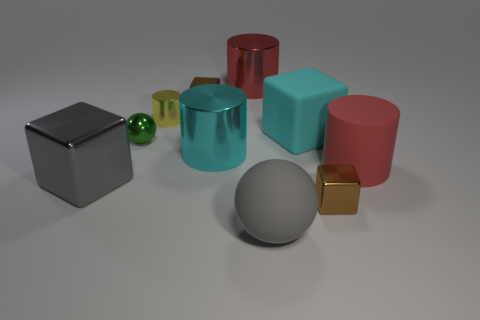What number of things are large yellow shiny cubes or big objects left of the large sphere?
Make the answer very short. 3. There is a small metal object in front of the big gray shiny thing in front of the red shiny object; what color is it?
Your response must be concise. Brown. What number of other things are the same material as the tiny green ball?
Ensure brevity in your answer.  6. What number of rubber things are either cyan cylinders or brown cylinders?
Provide a succinct answer. 0. What color is the other big metallic object that is the same shape as the red shiny thing?
Your response must be concise. Cyan. How many objects are big balls or red metallic things?
Make the answer very short. 2. There is a red object that is the same material as the large gray ball; what shape is it?
Provide a succinct answer. Cylinder. How many large things are either cyan metal cylinders or purple metal cylinders?
Your answer should be compact. 1. How many other objects are there of the same color as the big ball?
Offer a terse response. 1. There is a rubber object that is in front of the tiny brown metallic thing in front of the tiny cylinder; what number of large gray shiny cubes are in front of it?
Provide a short and direct response. 0. 